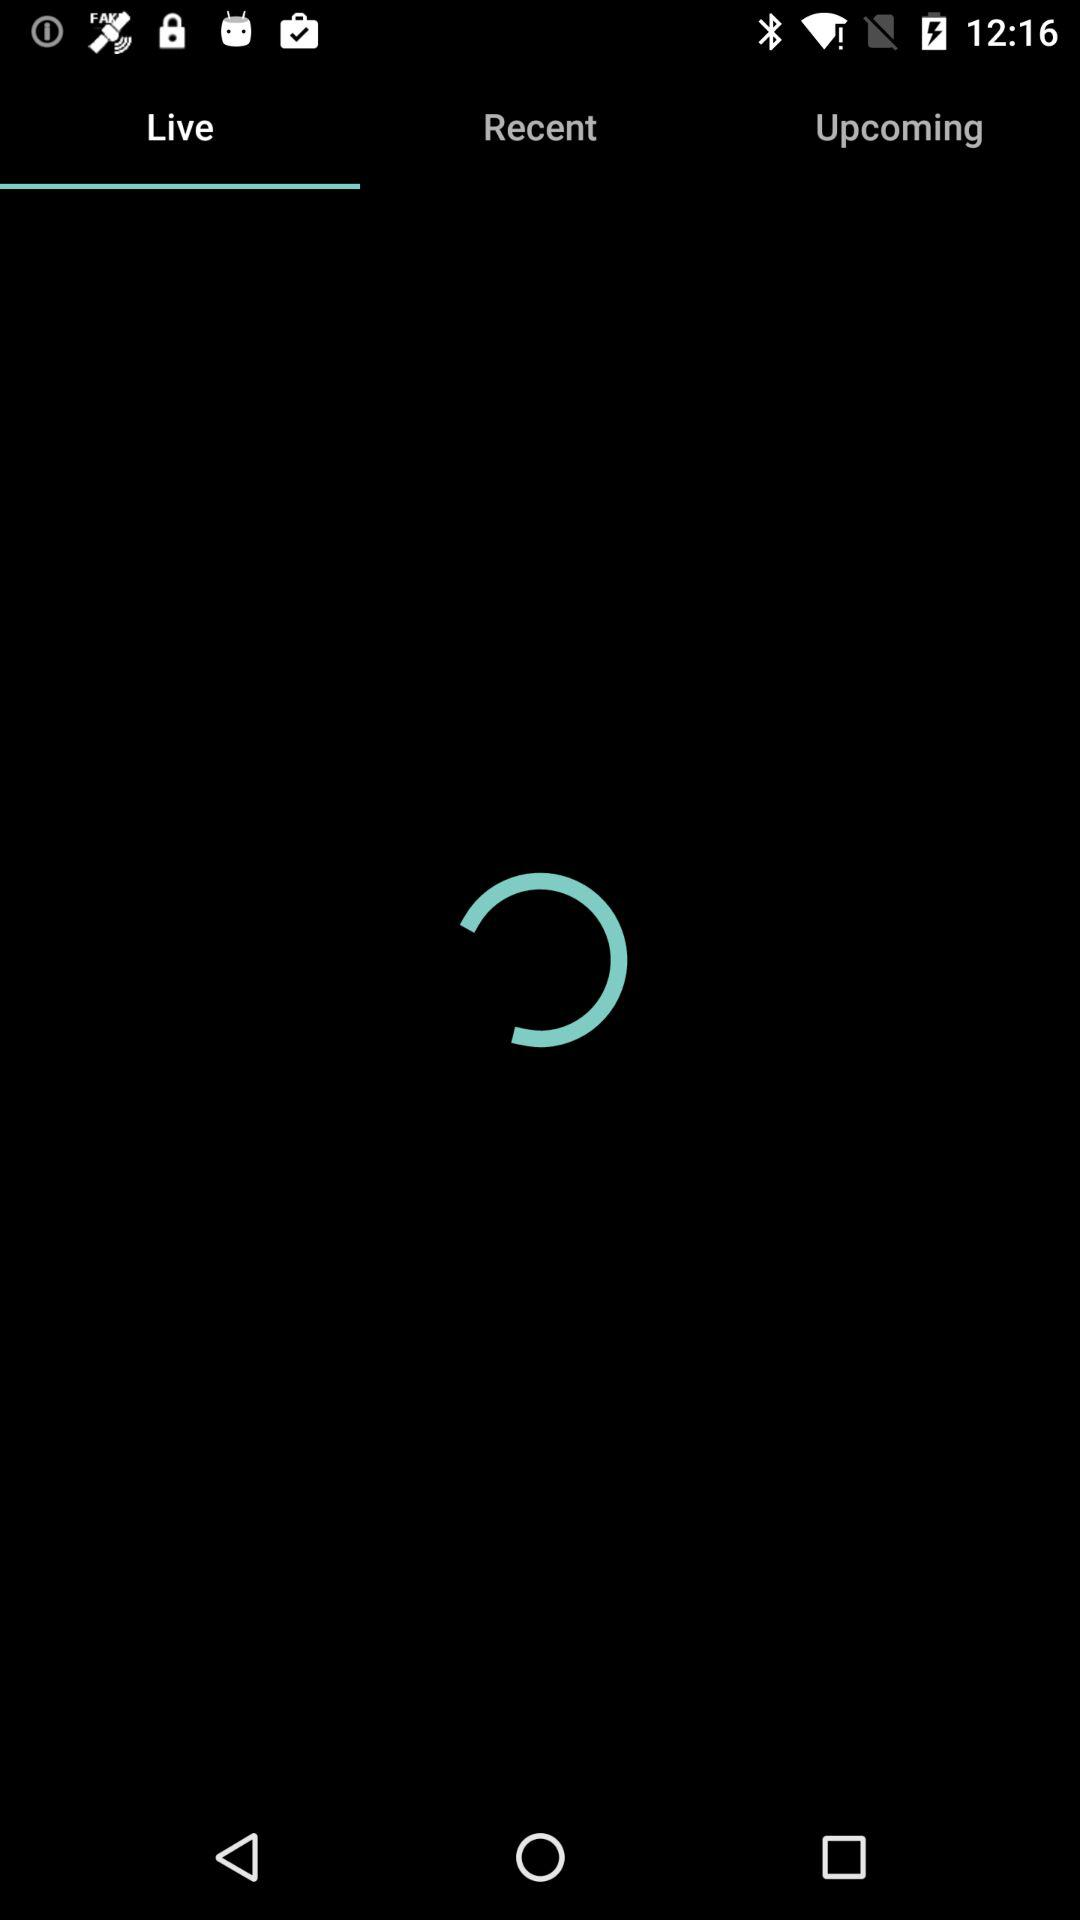Which tab has been selected? The selected tab is "Live". 